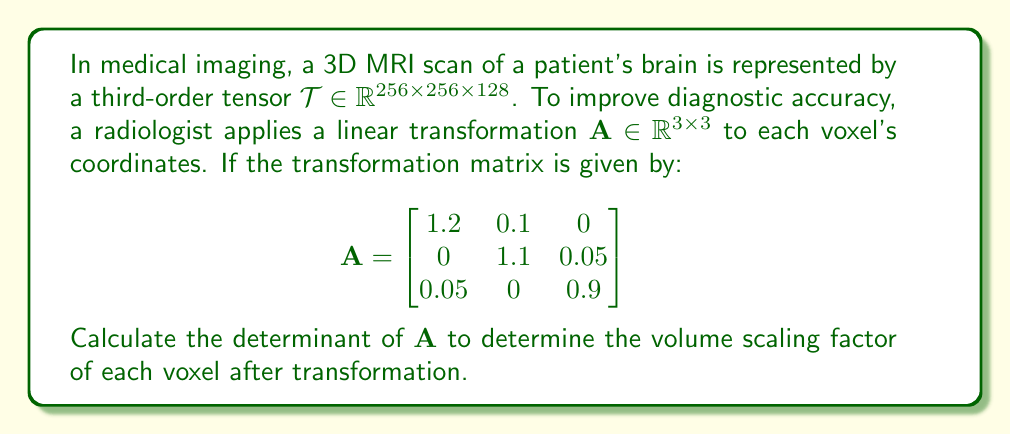Can you answer this question? To solve this problem, we need to calculate the determinant of the 3x3 matrix $\mathbf{A}$. The determinant will give us the volume scaling factor of each voxel after the transformation.

Step 1: Recall the formula for the determinant of a 3x3 matrix:
For a matrix $\mathbf{M} = \begin{bmatrix}
a & b & c \\
d & e & f \\
g & h & i
\end{bmatrix}$, 
the determinant is given by:
$$\det(\mathbf{M}) = a(ei-fh) - b(di-fg) + c(dh-eg)$$

Step 2: Identify the elements of matrix $\mathbf{A}$:
$a = 1.2$, $b = 0.1$, $c = 0$
$d = 0$, $e = 1.1$, $f = 0.05$
$g = 0.05$, $h = 0$, $i = 0.9$

Step 3: Calculate the determinant using the formula:
$$\begin{align*}
\det(\mathbf{A}) &= 1.2[(1.1)(0.9) - (0.05)(0)] \\
&\quad - 0.1[(0)(0.9) - (0.05)(0.05)] \\
&\quad + 0[(0)(0) - (1.1)(0.05)]
\end{align*}$$

Step 4: Simplify the calculation:
$$\begin{align*}
\det(\mathbf{A}) &= 1.2(0.99) - 0.1(0 - 0.0025) + 0 \\
&= 1.188 + 0.00025 \\
&= 1.18825
\end{align*}$$

Therefore, the determinant of $\mathbf{A}$ is approximately 1.18825.
Answer: $1.18825$ 